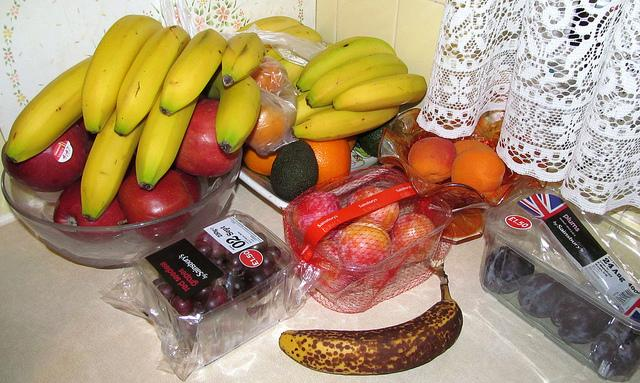What color is the banana without a bunch on the countertop directly? Please explain your reasoning. brown. The bananas in the bunch are yellow. the loose banana is overripened and is a different color. 